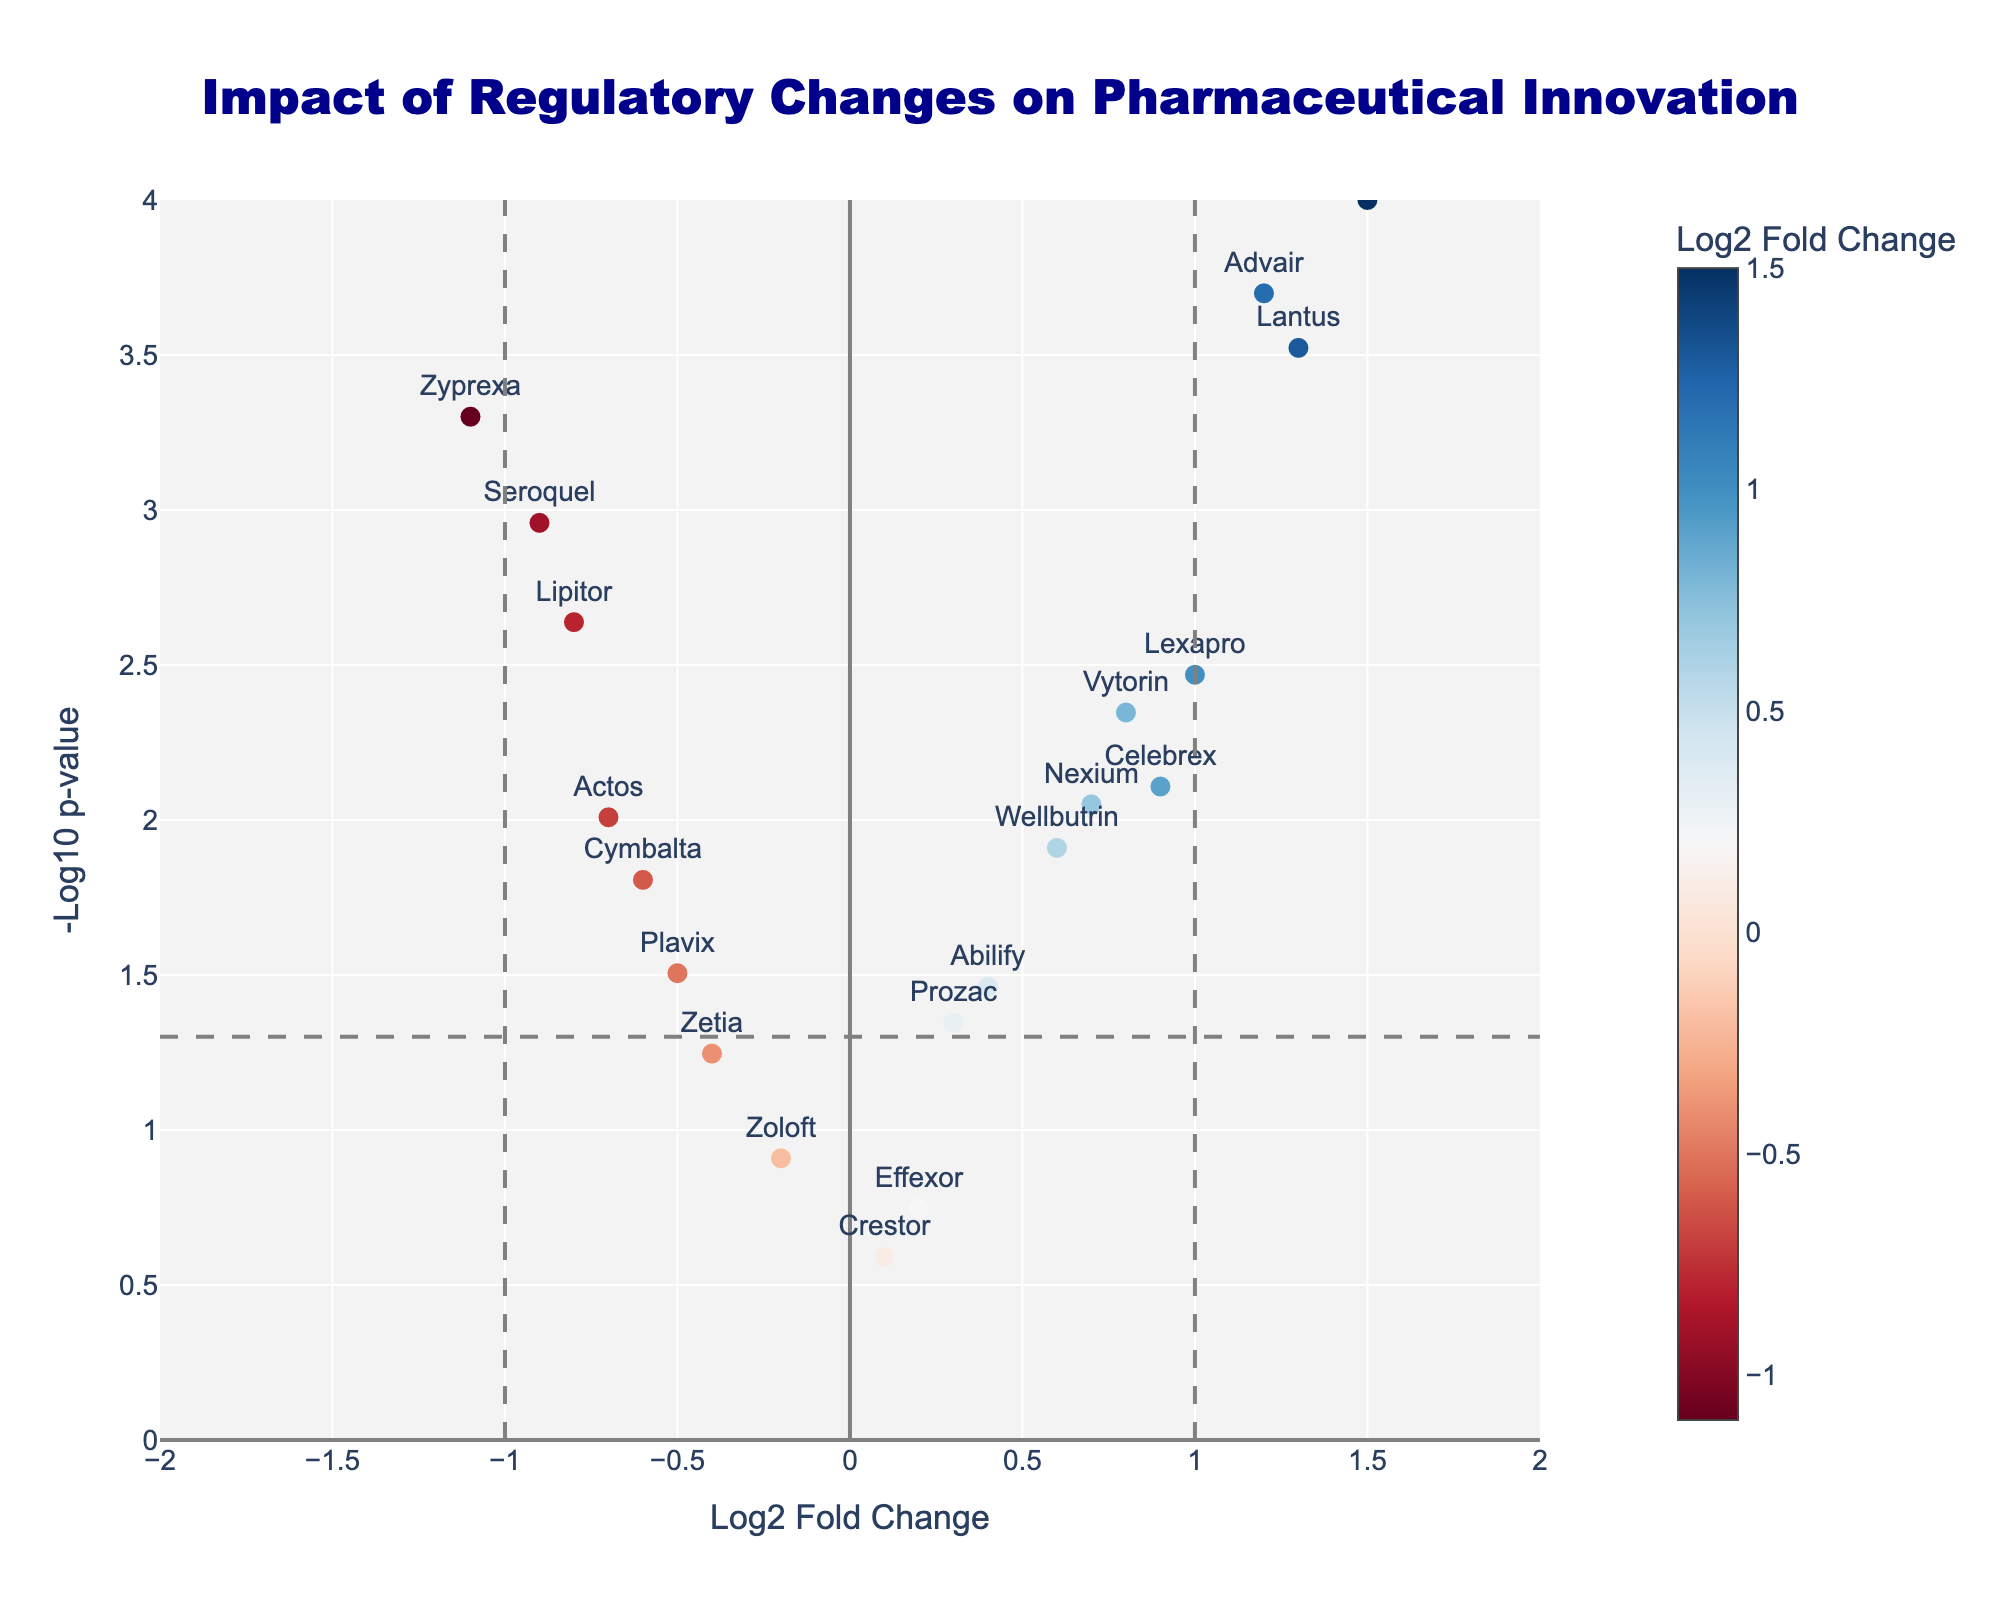What's the title of the plot? The title is found at the top of the plot. It is meant to give viewers a quick understanding of what the plot represents. In this case, the plot's title is very prominent and easily readable.
Answer: Impact of Regulatory Changes on Pharmaceutical Innovation What do the X and Y axes represent? The labels on the X and Y axes describe what each axis represents. The X-axis is labeled 'Log2 Fold Change', and the Y-axis is labeled '-Log10 p-value'.
Answer: Log2 Fold Change and -Log10 p-value How many data points are there in the plot? Each data point represents a drug. By counting the number of markers or labels present in the scatter plot, we can determine the total number of data points. There are 20 drug names visible.
Answer: 20 Which drug has the highest -log10 p-value? To find the highest -log10 p-value, look at the Y-axis and find the top-most point. Hover over it or read the label. In this case, it is Singulair.
Answer: Singulair Are there any drugs with a negative Log2 Fold Change but a significant p-value (less than 0.05)? To determine this, look at the data points with a Log2 Fold Change less than 0 and check if their Y-axis value (-log10 p-value) is above the threshold line at -log10(0.05). Drugs like Lipitor, Zyprexa, Seroquel, Cymbalta, and Plavix meet these criteria.
Answer: Yes, Lipitor, Zyprexa, Seroquel, Cymbalta, Plavix What is the log2 fold change for the drug with the most significant p-value? Identify the drug with the highest -log10 p-value and check its position on the X-axis. Singulair has the most significant p-value, and its Log2 Fold Change value is 1.5.
Answer: 1.5 Compare the fold change and significance between Advair and Actos. Which one has a greater impact and higher significance? Advair has a Log2 Fold Change of 1.2 and a p-value of 0.0002, while Actos has a Log2 Fold Change of -0.7 and a p-value of 0.0098. Both measures indicate that Advair has a greater positive impact and higher significance.
Answer: Advair How many drugs have a positive log2 fold change? Count the number of data points on the right side of the vertical line at Log2 Fold Change = 0. Each point represents a drug with a positive log2 fold change. You will count 11 drugs.
Answer: 11 What can you infer about the drugs with log2 fold change between -0.5 and 0.5? By examining the range of drugs between -0.5 and 0.5 on the X-axis, you notice that most points in this range have relatively lower -log10 p-values, suggesting they are less significant. These drugs include Prozac, Plavix, Zoloft, Crestor, Effexor, Abilify, and Wellbutrin. The inference is that these drugs show smaller changes and are not as statistically significant.
Answer: Smaller changes, not statistically significant What does a log2 fold change of 0 imply for the drug? A Log2 Fold Change of 0 indicates that there is no change between the before and after states evaluated in the study. Therefore, a drug with a log2 fold change of 0 is essentially unchanged by the regulatory changes. In this plot, there are no drugs at exactly 0, implying all observed drugs were impacted to some extent.
Answer: No change 